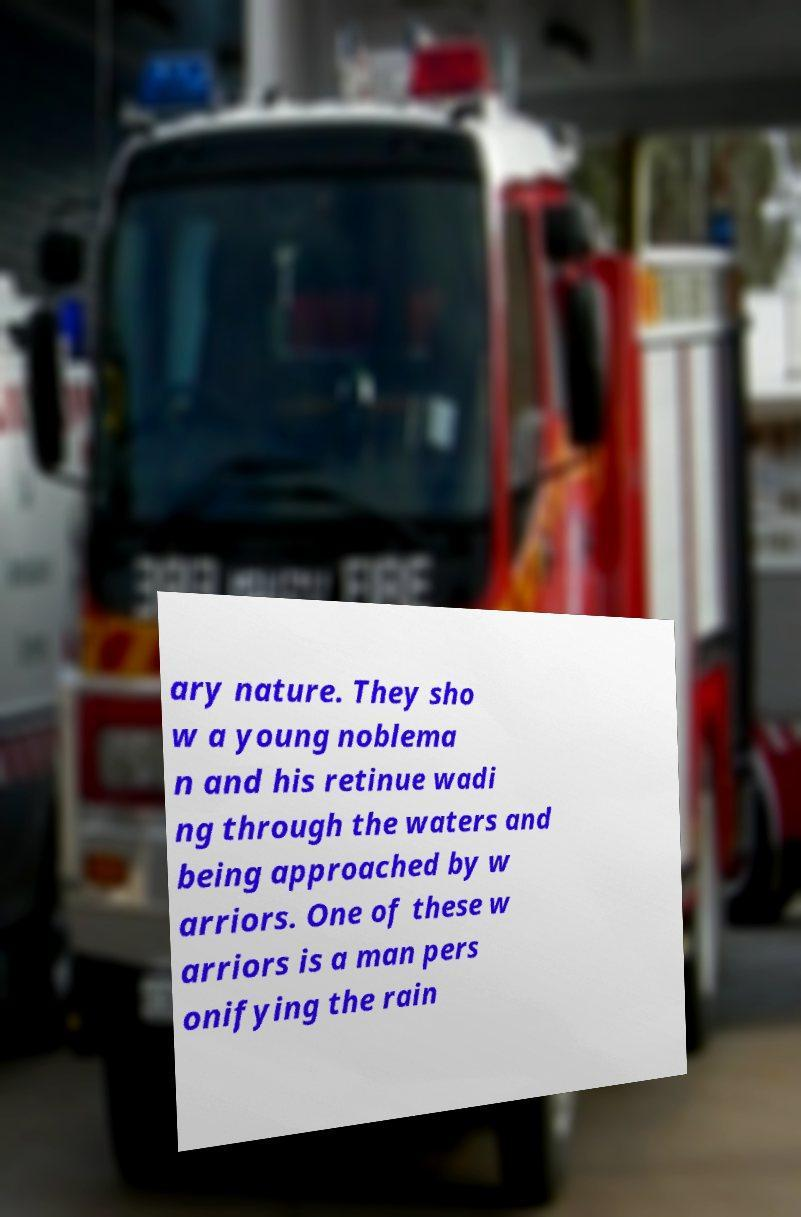Could you assist in decoding the text presented in this image and type it out clearly? ary nature. They sho w a young noblema n and his retinue wadi ng through the waters and being approached by w arriors. One of these w arriors is a man pers onifying the rain 